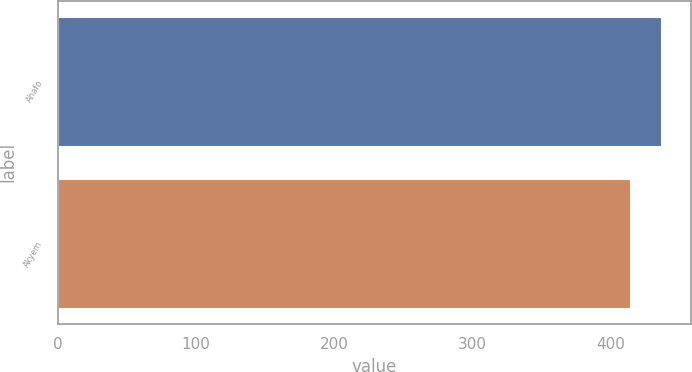<chart> <loc_0><loc_0><loc_500><loc_500><bar_chart><fcel>Ahafo<fcel>Akyem<nl><fcel>436<fcel>414<nl></chart> 